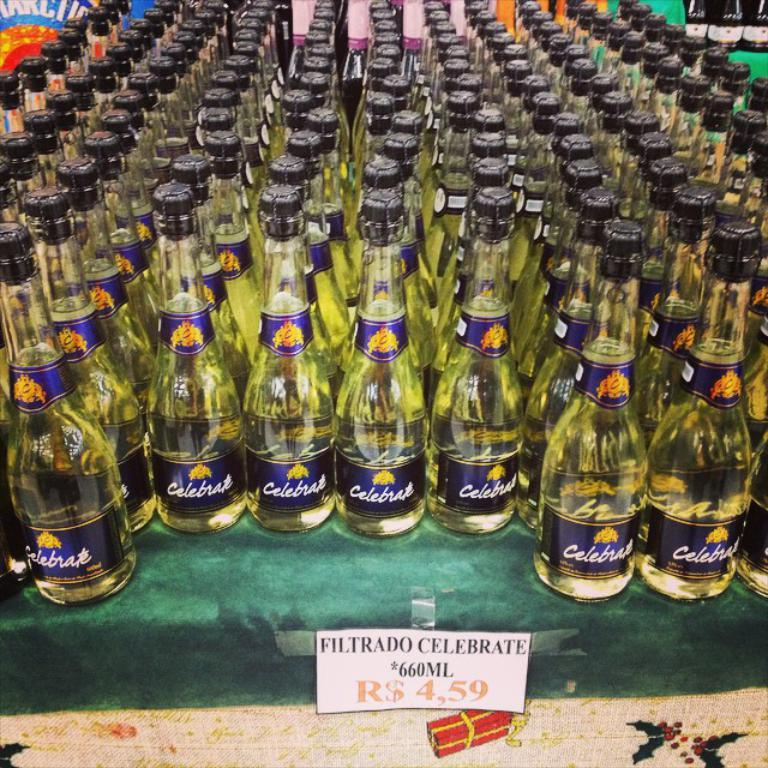<image>
Relay a brief, clear account of the picture shown. Hundreds of bottles of Filtrado Celebrate 660ML on a table with a green tablecloth. 